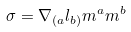<formula> <loc_0><loc_0><loc_500><loc_500>\sigma = \nabla _ { ( a } l _ { b ) } m ^ { a } m ^ { b }</formula> 